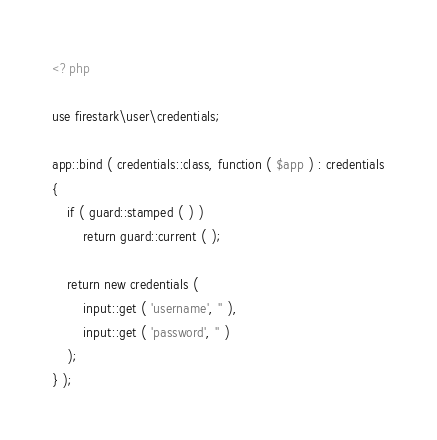Convert code to text. <code><loc_0><loc_0><loc_500><loc_500><_PHP_><?php

use firestark\user\credentials;

app::bind ( credentials::class, function ( $app ) : credentials
{
    if ( guard::stamped ( ) )
        return guard::current ( );

    return new credentials (
        input::get ( 'username', '' ),
        input::get ( 'password', '' )
    );
} );
</code> 